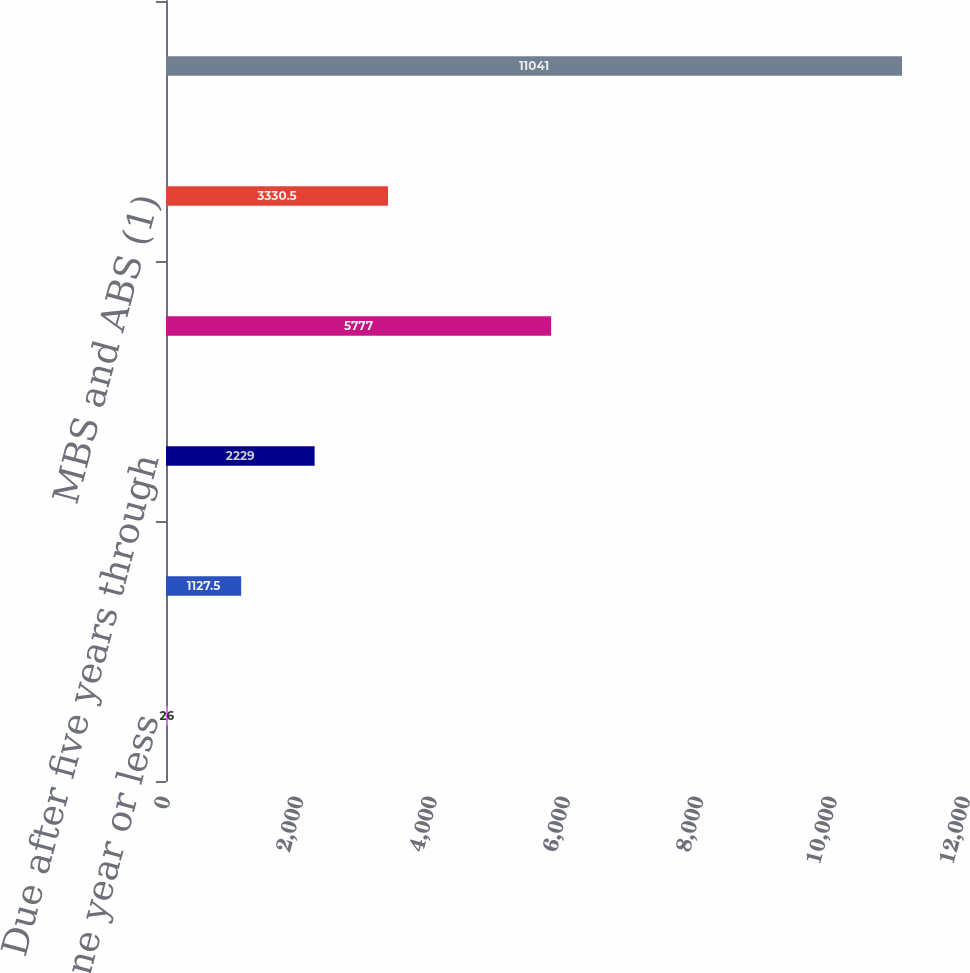Convert chart to OTSL. <chart><loc_0><loc_0><loc_500><loc_500><bar_chart><fcel>Due in one year or less<fcel>Due after one year through<fcel>Due after five years through<fcel>Due after ten years<fcel>MBS and ABS (1)<fcel>Total<nl><fcel>26<fcel>1127.5<fcel>2229<fcel>5777<fcel>3330.5<fcel>11041<nl></chart> 